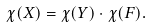Convert formula to latex. <formula><loc_0><loc_0><loc_500><loc_500>\chi ( X ) = \chi ( Y ) \cdot \chi ( F ) .</formula> 